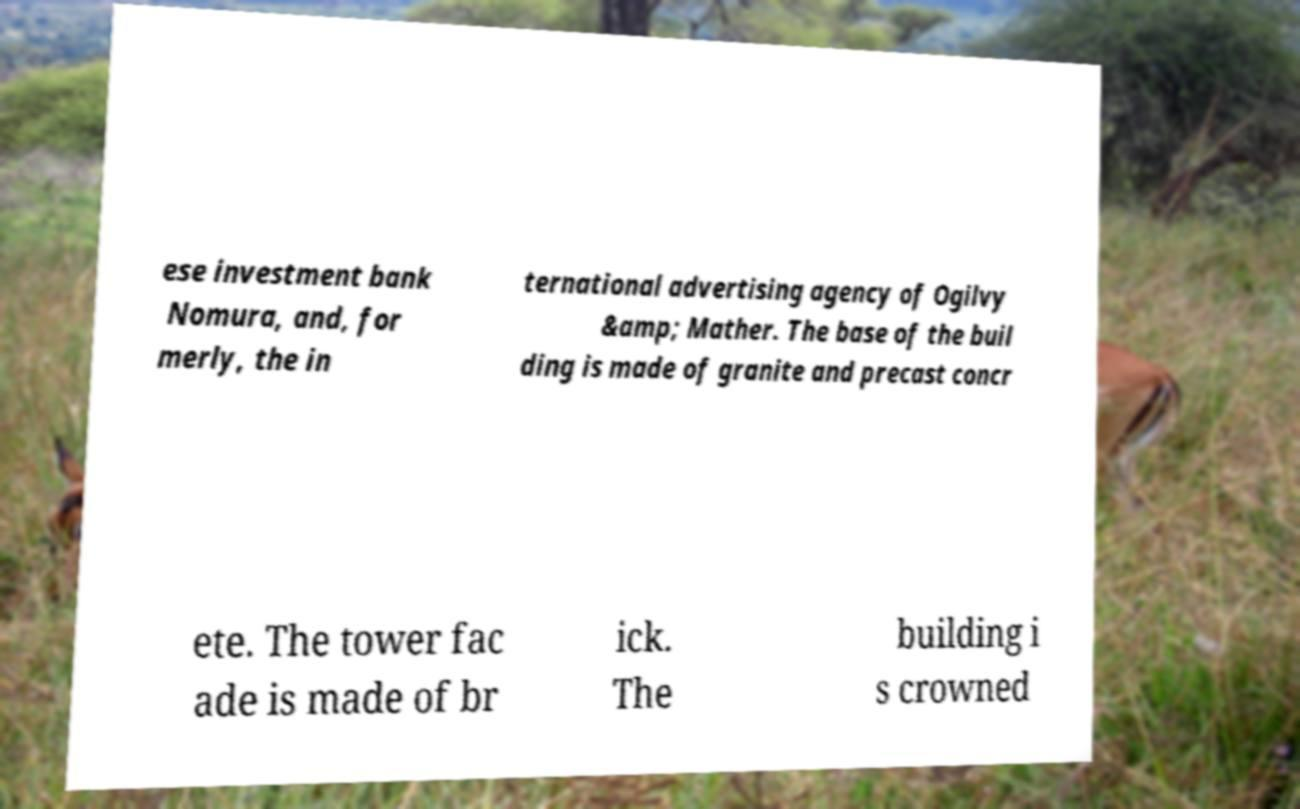Could you extract and type out the text from this image? ese investment bank Nomura, and, for merly, the in ternational advertising agency of Ogilvy &amp; Mather. The base of the buil ding is made of granite and precast concr ete. The tower fac ade is made of br ick. The building i s crowned 